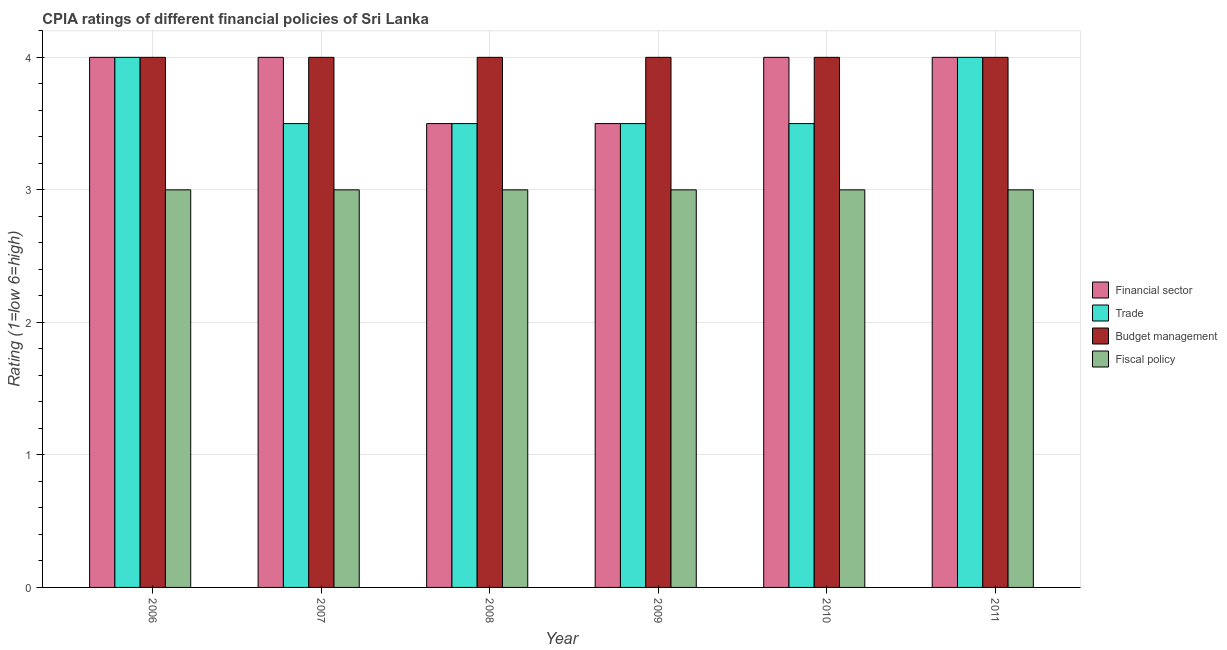How many different coloured bars are there?
Offer a terse response. 4. How many groups of bars are there?
Offer a very short reply. 6. Are the number of bars per tick equal to the number of legend labels?
Give a very brief answer. Yes. What is the cpia rating of budget management in 2009?
Offer a terse response. 4. Across all years, what is the maximum cpia rating of budget management?
Your response must be concise. 4. Across all years, what is the minimum cpia rating of budget management?
Your answer should be compact. 4. In which year was the cpia rating of financial sector maximum?
Make the answer very short. 2006. What is the difference between the cpia rating of budget management in 2009 and the cpia rating of trade in 2006?
Give a very brief answer. 0. What is the average cpia rating of financial sector per year?
Your response must be concise. 3.83. What is the ratio of the cpia rating of trade in 2010 to that in 2011?
Offer a very short reply. 0.88. Is the difference between the cpia rating of financial sector in 2009 and 2010 greater than the difference between the cpia rating of budget management in 2009 and 2010?
Your answer should be compact. No. Is it the case that in every year, the sum of the cpia rating of trade and cpia rating of financial sector is greater than the sum of cpia rating of budget management and cpia rating of fiscal policy?
Make the answer very short. No. What does the 4th bar from the left in 2007 represents?
Make the answer very short. Fiscal policy. What does the 4th bar from the right in 2007 represents?
Your response must be concise. Financial sector. How many bars are there?
Offer a terse response. 24. Are all the bars in the graph horizontal?
Your answer should be compact. No. What is the difference between two consecutive major ticks on the Y-axis?
Provide a short and direct response. 1. Does the graph contain any zero values?
Provide a short and direct response. No. How many legend labels are there?
Make the answer very short. 4. What is the title of the graph?
Provide a short and direct response. CPIA ratings of different financial policies of Sri Lanka. Does "Germany" appear as one of the legend labels in the graph?
Your answer should be very brief. No. What is the Rating (1=low 6=high) of Budget management in 2006?
Your answer should be very brief. 4. What is the Rating (1=low 6=high) of Financial sector in 2007?
Ensure brevity in your answer.  4. What is the Rating (1=low 6=high) of Trade in 2007?
Give a very brief answer. 3.5. What is the Rating (1=low 6=high) in Fiscal policy in 2007?
Offer a very short reply. 3. What is the Rating (1=low 6=high) of Trade in 2008?
Keep it short and to the point. 3.5. What is the Rating (1=low 6=high) in Budget management in 2008?
Offer a very short reply. 4. What is the Rating (1=low 6=high) in Fiscal policy in 2008?
Ensure brevity in your answer.  3. What is the Rating (1=low 6=high) in Trade in 2009?
Your answer should be very brief. 3.5. What is the Rating (1=low 6=high) in Budget management in 2009?
Your answer should be compact. 4. What is the Rating (1=low 6=high) in Fiscal policy in 2009?
Ensure brevity in your answer.  3. What is the Rating (1=low 6=high) in Financial sector in 2010?
Keep it short and to the point. 4. Across all years, what is the maximum Rating (1=low 6=high) of Trade?
Make the answer very short. 4. Across all years, what is the minimum Rating (1=low 6=high) of Fiscal policy?
Offer a terse response. 3. What is the total Rating (1=low 6=high) of Trade in the graph?
Provide a short and direct response. 22. What is the difference between the Rating (1=low 6=high) of Financial sector in 2006 and that in 2007?
Provide a succinct answer. 0. What is the difference between the Rating (1=low 6=high) of Budget management in 2006 and that in 2007?
Provide a short and direct response. 0. What is the difference between the Rating (1=low 6=high) in Trade in 2006 and that in 2008?
Provide a short and direct response. 0.5. What is the difference between the Rating (1=low 6=high) of Budget management in 2006 and that in 2009?
Provide a succinct answer. 0. What is the difference between the Rating (1=low 6=high) in Fiscal policy in 2006 and that in 2009?
Your answer should be compact. 0. What is the difference between the Rating (1=low 6=high) of Financial sector in 2006 and that in 2010?
Your response must be concise. 0. What is the difference between the Rating (1=low 6=high) of Fiscal policy in 2006 and that in 2010?
Your answer should be very brief. 0. What is the difference between the Rating (1=low 6=high) of Fiscal policy in 2006 and that in 2011?
Your answer should be very brief. 0. What is the difference between the Rating (1=low 6=high) of Financial sector in 2007 and that in 2009?
Your answer should be compact. 0.5. What is the difference between the Rating (1=low 6=high) in Trade in 2007 and that in 2009?
Make the answer very short. 0. What is the difference between the Rating (1=low 6=high) of Budget management in 2007 and that in 2009?
Ensure brevity in your answer.  0. What is the difference between the Rating (1=low 6=high) of Fiscal policy in 2007 and that in 2009?
Your answer should be very brief. 0. What is the difference between the Rating (1=low 6=high) in Financial sector in 2007 and that in 2010?
Your answer should be compact. 0. What is the difference between the Rating (1=low 6=high) of Trade in 2007 and that in 2010?
Your answer should be compact. 0. What is the difference between the Rating (1=low 6=high) in Budget management in 2007 and that in 2010?
Give a very brief answer. 0. What is the difference between the Rating (1=low 6=high) in Fiscal policy in 2007 and that in 2010?
Your answer should be very brief. 0. What is the difference between the Rating (1=low 6=high) in Financial sector in 2007 and that in 2011?
Provide a succinct answer. 0. What is the difference between the Rating (1=low 6=high) in Financial sector in 2008 and that in 2009?
Provide a succinct answer. 0. What is the difference between the Rating (1=low 6=high) of Budget management in 2008 and that in 2009?
Keep it short and to the point. 0. What is the difference between the Rating (1=low 6=high) in Fiscal policy in 2008 and that in 2009?
Ensure brevity in your answer.  0. What is the difference between the Rating (1=low 6=high) in Financial sector in 2008 and that in 2010?
Make the answer very short. -0.5. What is the difference between the Rating (1=low 6=high) in Trade in 2008 and that in 2010?
Offer a terse response. 0. What is the difference between the Rating (1=low 6=high) of Financial sector in 2008 and that in 2011?
Offer a terse response. -0.5. What is the difference between the Rating (1=low 6=high) in Fiscal policy in 2008 and that in 2011?
Offer a very short reply. 0. What is the difference between the Rating (1=low 6=high) of Trade in 2009 and that in 2010?
Make the answer very short. 0. What is the difference between the Rating (1=low 6=high) in Budget management in 2009 and that in 2010?
Provide a short and direct response. 0. What is the difference between the Rating (1=low 6=high) of Budget management in 2009 and that in 2011?
Ensure brevity in your answer.  0. What is the difference between the Rating (1=low 6=high) in Fiscal policy in 2010 and that in 2011?
Provide a short and direct response. 0. What is the difference between the Rating (1=low 6=high) in Financial sector in 2006 and the Rating (1=low 6=high) in Trade in 2007?
Your answer should be compact. 0.5. What is the difference between the Rating (1=low 6=high) of Financial sector in 2006 and the Rating (1=low 6=high) of Fiscal policy in 2007?
Your answer should be compact. 1. What is the difference between the Rating (1=low 6=high) in Trade in 2006 and the Rating (1=low 6=high) in Fiscal policy in 2007?
Provide a succinct answer. 1. What is the difference between the Rating (1=low 6=high) in Budget management in 2006 and the Rating (1=low 6=high) in Fiscal policy in 2007?
Your answer should be compact. 1. What is the difference between the Rating (1=low 6=high) in Trade in 2006 and the Rating (1=low 6=high) in Budget management in 2008?
Your response must be concise. 0. What is the difference between the Rating (1=low 6=high) of Trade in 2006 and the Rating (1=low 6=high) of Fiscal policy in 2008?
Make the answer very short. 1. What is the difference between the Rating (1=low 6=high) in Budget management in 2006 and the Rating (1=low 6=high) in Fiscal policy in 2008?
Make the answer very short. 1. What is the difference between the Rating (1=low 6=high) in Trade in 2006 and the Rating (1=low 6=high) in Fiscal policy in 2009?
Ensure brevity in your answer.  1. What is the difference between the Rating (1=low 6=high) of Budget management in 2006 and the Rating (1=low 6=high) of Fiscal policy in 2009?
Offer a very short reply. 1. What is the difference between the Rating (1=low 6=high) of Financial sector in 2006 and the Rating (1=low 6=high) of Trade in 2010?
Give a very brief answer. 0.5. What is the difference between the Rating (1=low 6=high) in Trade in 2006 and the Rating (1=low 6=high) in Budget management in 2010?
Provide a short and direct response. 0. What is the difference between the Rating (1=low 6=high) in Trade in 2006 and the Rating (1=low 6=high) in Budget management in 2011?
Offer a terse response. 0. What is the difference between the Rating (1=low 6=high) in Financial sector in 2007 and the Rating (1=low 6=high) in Budget management in 2008?
Your response must be concise. 0. What is the difference between the Rating (1=low 6=high) in Financial sector in 2007 and the Rating (1=low 6=high) in Fiscal policy in 2008?
Give a very brief answer. 1. What is the difference between the Rating (1=low 6=high) in Trade in 2007 and the Rating (1=low 6=high) in Budget management in 2008?
Offer a very short reply. -0.5. What is the difference between the Rating (1=low 6=high) of Trade in 2007 and the Rating (1=low 6=high) of Fiscal policy in 2008?
Your answer should be very brief. 0.5. What is the difference between the Rating (1=low 6=high) of Budget management in 2007 and the Rating (1=low 6=high) of Fiscal policy in 2008?
Keep it short and to the point. 1. What is the difference between the Rating (1=low 6=high) in Financial sector in 2007 and the Rating (1=low 6=high) in Budget management in 2009?
Keep it short and to the point. 0. What is the difference between the Rating (1=low 6=high) of Financial sector in 2007 and the Rating (1=low 6=high) of Fiscal policy in 2009?
Your answer should be very brief. 1. What is the difference between the Rating (1=low 6=high) in Trade in 2007 and the Rating (1=low 6=high) in Budget management in 2009?
Ensure brevity in your answer.  -0.5. What is the difference between the Rating (1=low 6=high) in Trade in 2007 and the Rating (1=low 6=high) in Fiscal policy in 2009?
Offer a very short reply. 0.5. What is the difference between the Rating (1=low 6=high) of Budget management in 2007 and the Rating (1=low 6=high) of Fiscal policy in 2009?
Ensure brevity in your answer.  1. What is the difference between the Rating (1=low 6=high) in Financial sector in 2007 and the Rating (1=low 6=high) in Budget management in 2010?
Your answer should be compact. 0. What is the difference between the Rating (1=low 6=high) of Financial sector in 2007 and the Rating (1=low 6=high) of Fiscal policy in 2010?
Offer a very short reply. 1. What is the difference between the Rating (1=low 6=high) in Trade in 2007 and the Rating (1=low 6=high) in Fiscal policy in 2010?
Keep it short and to the point. 0.5. What is the difference between the Rating (1=low 6=high) in Budget management in 2007 and the Rating (1=low 6=high) in Fiscal policy in 2010?
Make the answer very short. 1. What is the difference between the Rating (1=low 6=high) in Financial sector in 2007 and the Rating (1=low 6=high) in Trade in 2011?
Give a very brief answer. 0. What is the difference between the Rating (1=low 6=high) in Financial sector in 2007 and the Rating (1=low 6=high) in Budget management in 2011?
Keep it short and to the point. 0. What is the difference between the Rating (1=low 6=high) of Trade in 2007 and the Rating (1=low 6=high) of Budget management in 2011?
Give a very brief answer. -0.5. What is the difference between the Rating (1=low 6=high) of Budget management in 2007 and the Rating (1=low 6=high) of Fiscal policy in 2011?
Your answer should be compact. 1. What is the difference between the Rating (1=low 6=high) in Financial sector in 2008 and the Rating (1=low 6=high) in Fiscal policy in 2009?
Ensure brevity in your answer.  0.5. What is the difference between the Rating (1=low 6=high) of Trade in 2008 and the Rating (1=low 6=high) of Budget management in 2009?
Your response must be concise. -0.5. What is the difference between the Rating (1=low 6=high) in Budget management in 2008 and the Rating (1=low 6=high) in Fiscal policy in 2009?
Provide a succinct answer. 1. What is the difference between the Rating (1=low 6=high) of Financial sector in 2008 and the Rating (1=low 6=high) of Trade in 2010?
Keep it short and to the point. 0. What is the difference between the Rating (1=low 6=high) in Financial sector in 2008 and the Rating (1=low 6=high) in Budget management in 2010?
Keep it short and to the point. -0.5. What is the difference between the Rating (1=low 6=high) in Financial sector in 2008 and the Rating (1=low 6=high) in Fiscal policy in 2010?
Make the answer very short. 0.5. What is the difference between the Rating (1=low 6=high) of Trade in 2008 and the Rating (1=low 6=high) of Budget management in 2010?
Offer a very short reply. -0.5. What is the difference between the Rating (1=low 6=high) in Financial sector in 2008 and the Rating (1=low 6=high) in Trade in 2011?
Give a very brief answer. -0.5. What is the difference between the Rating (1=low 6=high) in Financial sector in 2008 and the Rating (1=low 6=high) in Budget management in 2011?
Give a very brief answer. -0.5. What is the difference between the Rating (1=low 6=high) in Trade in 2008 and the Rating (1=low 6=high) in Budget management in 2011?
Provide a succinct answer. -0.5. What is the difference between the Rating (1=low 6=high) of Trade in 2008 and the Rating (1=low 6=high) of Fiscal policy in 2011?
Your response must be concise. 0.5. What is the difference between the Rating (1=low 6=high) of Financial sector in 2009 and the Rating (1=low 6=high) of Trade in 2010?
Provide a short and direct response. 0. What is the difference between the Rating (1=low 6=high) in Financial sector in 2009 and the Rating (1=low 6=high) in Budget management in 2010?
Your response must be concise. -0.5. What is the difference between the Rating (1=low 6=high) of Trade in 2009 and the Rating (1=low 6=high) of Fiscal policy in 2010?
Offer a terse response. 0.5. What is the difference between the Rating (1=low 6=high) of Budget management in 2009 and the Rating (1=low 6=high) of Fiscal policy in 2010?
Offer a very short reply. 1. What is the difference between the Rating (1=low 6=high) of Financial sector in 2009 and the Rating (1=low 6=high) of Budget management in 2011?
Provide a short and direct response. -0.5. What is the difference between the Rating (1=low 6=high) in Trade in 2009 and the Rating (1=low 6=high) in Budget management in 2011?
Your answer should be very brief. -0.5. What is the difference between the Rating (1=low 6=high) in Budget management in 2009 and the Rating (1=low 6=high) in Fiscal policy in 2011?
Ensure brevity in your answer.  1. What is the difference between the Rating (1=low 6=high) of Financial sector in 2010 and the Rating (1=low 6=high) of Budget management in 2011?
Provide a succinct answer. 0. What is the difference between the Rating (1=low 6=high) of Trade in 2010 and the Rating (1=low 6=high) of Budget management in 2011?
Give a very brief answer. -0.5. What is the average Rating (1=low 6=high) in Financial sector per year?
Keep it short and to the point. 3.83. What is the average Rating (1=low 6=high) in Trade per year?
Your answer should be compact. 3.67. What is the average Rating (1=low 6=high) in Budget management per year?
Your answer should be very brief. 4. In the year 2006, what is the difference between the Rating (1=low 6=high) in Financial sector and Rating (1=low 6=high) in Trade?
Offer a terse response. 0. In the year 2006, what is the difference between the Rating (1=low 6=high) of Financial sector and Rating (1=low 6=high) of Budget management?
Your answer should be very brief. 0. In the year 2006, what is the difference between the Rating (1=low 6=high) in Budget management and Rating (1=low 6=high) in Fiscal policy?
Provide a succinct answer. 1. In the year 2007, what is the difference between the Rating (1=low 6=high) of Financial sector and Rating (1=low 6=high) of Trade?
Provide a short and direct response. 0.5. In the year 2007, what is the difference between the Rating (1=low 6=high) of Trade and Rating (1=low 6=high) of Fiscal policy?
Provide a short and direct response. 0.5. In the year 2007, what is the difference between the Rating (1=low 6=high) in Budget management and Rating (1=low 6=high) in Fiscal policy?
Give a very brief answer. 1. In the year 2008, what is the difference between the Rating (1=low 6=high) of Financial sector and Rating (1=low 6=high) of Trade?
Give a very brief answer. 0. In the year 2008, what is the difference between the Rating (1=low 6=high) of Trade and Rating (1=low 6=high) of Budget management?
Give a very brief answer. -0.5. In the year 2008, what is the difference between the Rating (1=low 6=high) of Trade and Rating (1=low 6=high) of Fiscal policy?
Your answer should be very brief. 0.5. In the year 2008, what is the difference between the Rating (1=low 6=high) in Budget management and Rating (1=low 6=high) in Fiscal policy?
Your answer should be very brief. 1. In the year 2009, what is the difference between the Rating (1=low 6=high) of Financial sector and Rating (1=low 6=high) of Budget management?
Offer a terse response. -0.5. In the year 2009, what is the difference between the Rating (1=low 6=high) in Financial sector and Rating (1=low 6=high) in Fiscal policy?
Your response must be concise. 0.5. In the year 2009, what is the difference between the Rating (1=low 6=high) of Trade and Rating (1=low 6=high) of Budget management?
Provide a succinct answer. -0.5. In the year 2009, what is the difference between the Rating (1=low 6=high) in Trade and Rating (1=low 6=high) in Fiscal policy?
Ensure brevity in your answer.  0.5. In the year 2010, what is the difference between the Rating (1=low 6=high) in Financial sector and Rating (1=low 6=high) in Budget management?
Your answer should be compact. 0. In the year 2010, what is the difference between the Rating (1=low 6=high) in Trade and Rating (1=low 6=high) in Budget management?
Ensure brevity in your answer.  -0.5. In the year 2010, what is the difference between the Rating (1=low 6=high) of Budget management and Rating (1=low 6=high) of Fiscal policy?
Your answer should be very brief. 1. In the year 2011, what is the difference between the Rating (1=low 6=high) in Financial sector and Rating (1=low 6=high) in Fiscal policy?
Your response must be concise. 1. In the year 2011, what is the difference between the Rating (1=low 6=high) of Trade and Rating (1=low 6=high) of Budget management?
Offer a very short reply. 0. In the year 2011, what is the difference between the Rating (1=low 6=high) of Budget management and Rating (1=low 6=high) of Fiscal policy?
Your answer should be compact. 1. What is the ratio of the Rating (1=low 6=high) in Trade in 2006 to that in 2007?
Your answer should be compact. 1.14. What is the ratio of the Rating (1=low 6=high) of Budget management in 2006 to that in 2007?
Make the answer very short. 1. What is the ratio of the Rating (1=low 6=high) in Fiscal policy in 2006 to that in 2007?
Give a very brief answer. 1. What is the ratio of the Rating (1=low 6=high) of Trade in 2006 to that in 2008?
Provide a short and direct response. 1.14. What is the ratio of the Rating (1=low 6=high) of Fiscal policy in 2006 to that in 2008?
Provide a succinct answer. 1. What is the ratio of the Rating (1=low 6=high) of Trade in 2006 to that in 2009?
Offer a very short reply. 1.14. What is the ratio of the Rating (1=low 6=high) of Fiscal policy in 2006 to that in 2009?
Offer a very short reply. 1. What is the ratio of the Rating (1=low 6=high) in Financial sector in 2006 to that in 2010?
Provide a short and direct response. 1. What is the ratio of the Rating (1=low 6=high) of Trade in 2006 to that in 2010?
Keep it short and to the point. 1.14. What is the ratio of the Rating (1=low 6=high) in Budget management in 2006 to that in 2010?
Provide a short and direct response. 1. What is the ratio of the Rating (1=low 6=high) of Fiscal policy in 2006 to that in 2010?
Ensure brevity in your answer.  1. What is the ratio of the Rating (1=low 6=high) in Trade in 2006 to that in 2011?
Your answer should be very brief. 1. What is the ratio of the Rating (1=low 6=high) in Budget management in 2006 to that in 2011?
Ensure brevity in your answer.  1. What is the ratio of the Rating (1=low 6=high) in Fiscal policy in 2006 to that in 2011?
Ensure brevity in your answer.  1. What is the ratio of the Rating (1=low 6=high) of Trade in 2007 to that in 2008?
Provide a succinct answer. 1. What is the ratio of the Rating (1=low 6=high) of Budget management in 2007 to that in 2008?
Your answer should be compact. 1. What is the ratio of the Rating (1=low 6=high) of Budget management in 2007 to that in 2009?
Keep it short and to the point. 1. What is the ratio of the Rating (1=low 6=high) in Trade in 2007 to that in 2010?
Give a very brief answer. 1. What is the ratio of the Rating (1=low 6=high) of Fiscal policy in 2007 to that in 2011?
Offer a terse response. 1. What is the ratio of the Rating (1=low 6=high) of Financial sector in 2008 to that in 2010?
Offer a terse response. 0.88. What is the ratio of the Rating (1=low 6=high) of Trade in 2008 to that in 2010?
Keep it short and to the point. 1. What is the ratio of the Rating (1=low 6=high) of Financial sector in 2008 to that in 2011?
Your answer should be compact. 0.88. What is the ratio of the Rating (1=low 6=high) of Trade in 2008 to that in 2011?
Make the answer very short. 0.88. What is the ratio of the Rating (1=low 6=high) in Budget management in 2008 to that in 2011?
Your answer should be very brief. 1. What is the ratio of the Rating (1=low 6=high) in Fiscal policy in 2008 to that in 2011?
Ensure brevity in your answer.  1. What is the ratio of the Rating (1=low 6=high) of Financial sector in 2009 to that in 2010?
Provide a succinct answer. 0.88. What is the ratio of the Rating (1=low 6=high) in Trade in 2009 to that in 2010?
Your answer should be very brief. 1. What is the ratio of the Rating (1=low 6=high) of Budget management in 2009 to that in 2010?
Provide a short and direct response. 1. What is the ratio of the Rating (1=low 6=high) in Financial sector in 2009 to that in 2011?
Provide a succinct answer. 0.88. What is the ratio of the Rating (1=low 6=high) in Trade in 2009 to that in 2011?
Your response must be concise. 0.88. What is the ratio of the Rating (1=low 6=high) in Fiscal policy in 2010 to that in 2011?
Offer a very short reply. 1. What is the difference between the highest and the second highest Rating (1=low 6=high) of Financial sector?
Keep it short and to the point. 0. What is the difference between the highest and the second highest Rating (1=low 6=high) of Budget management?
Offer a terse response. 0. What is the difference between the highest and the second highest Rating (1=low 6=high) in Fiscal policy?
Provide a short and direct response. 0. What is the difference between the highest and the lowest Rating (1=low 6=high) in Financial sector?
Ensure brevity in your answer.  0.5. What is the difference between the highest and the lowest Rating (1=low 6=high) of Budget management?
Give a very brief answer. 0. 